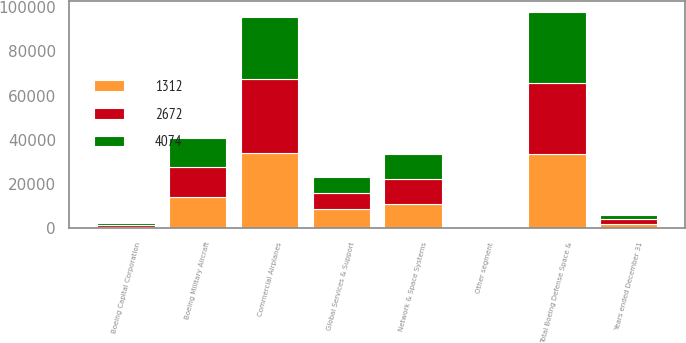Convert chart to OTSL. <chart><loc_0><loc_0><loc_500><loc_500><stacked_bar_chart><ecel><fcel>Years ended December 31<fcel>Commercial Airplanes<fcel>Boeing Military Aircraft<fcel>Network & Space Systems<fcel>Global Services & Support<fcel>Total Boeing Defense Space &<fcel>Boeing Capital Corporation<fcel>Other segment<nl><fcel>1312<fcel>2009<fcel>34051<fcel>14057<fcel>10877<fcel>8727<fcel>33661<fcel>660<fcel>165<nl><fcel>4074<fcel>2008<fcel>28263<fcel>13311<fcel>11346<fcel>7390<fcel>32047<fcel>703<fcel>567<nl><fcel>2672<fcel>2007<fcel>33386<fcel>13499<fcel>11481<fcel>7072<fcel>32052<fcel>815<fcel>308<nl></chart> 